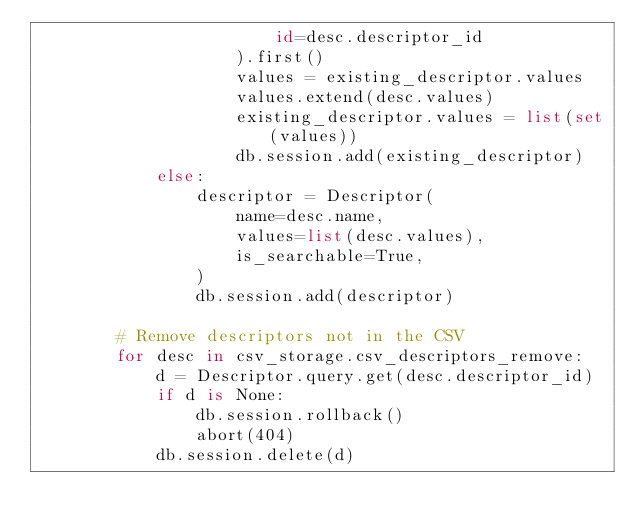<code> <loc_0><loc_0><loc_500><loc_500><_Python_>                        id=desc.descriptor_id
                    ).first()
                    values = existing_descriptor.values
                    values.extend(desc.values)
                    existing_descriptor.values = list(set(values))
                    db.session.add(existing_descriptor)
            else:
                descriptor = Descriptor(
                    name=desc.name,
                    values=list(desc.values),
                    is_searchable=True,
                )
                db.session.add(descriptor)

        # Remove descriptors not in the CSV
        for desc in csv_storage.csv_descriptors_remove:
            d = Descriptor.query.get(desc.descriptor_id)
            if d is None:
                db.session.rollback()
                abort(404)
            db.session.delete(d)
</code> 